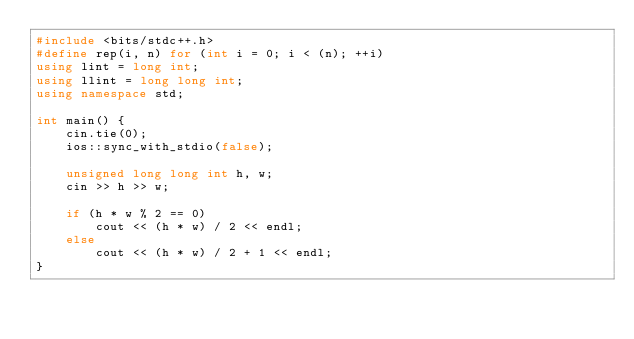Convert code to text. <code><loc_0><loc_0><loc_500><loc_500><_C++_>#include <bits/stdc++.h>
#define rep(i, n) for (int i = 0; i < (n); ++i)
using lint = long int;
using llint = long long int;
using namespace std;

int main() {
    cin.tie(0);
    ios::sync_with_stdio(false);

    unsigned long long int h, w;
    cin >> h >> w;

    if (h * w % 2 == 0)
        cout << (h * w) / 2 << endl;
    else
        cout << (h * w) / 2 + 1 << endl;
}
</code> 